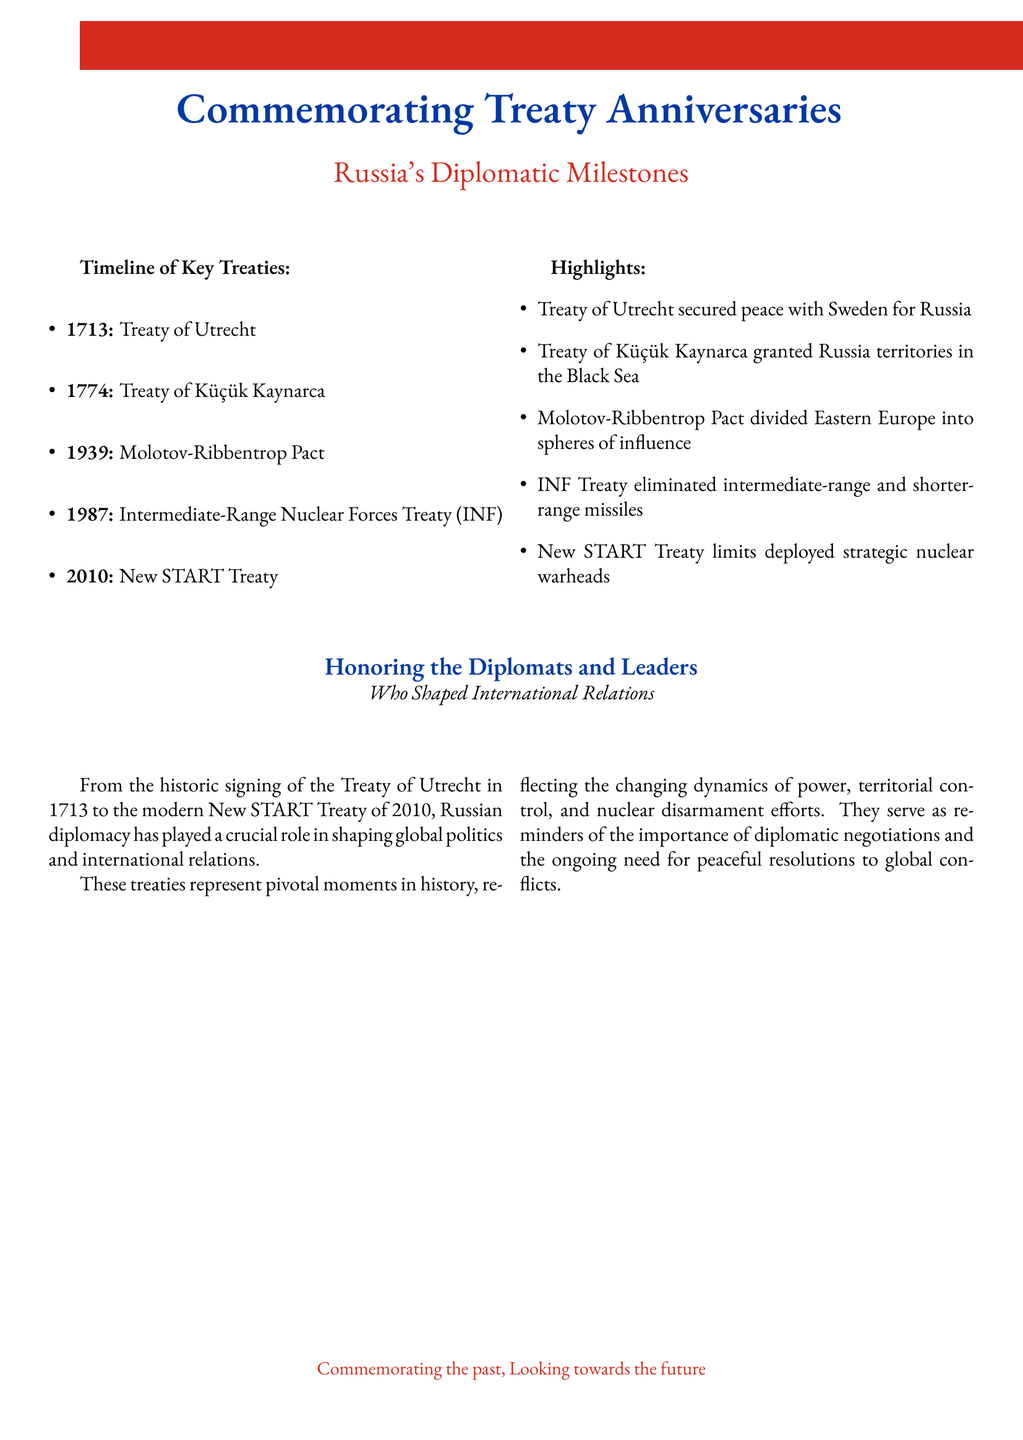what year was the Treaty of Utrecht signed? The Treaty of Utrecht was signed in 1713, as indicated in the timeline section of the document.
Answer: 1713 what treaty granted Russia territory in the Black Sea? The treaty that granted Russia territories in the Black Sea is the Treaty of Küçük Kaynarca, as noted in the highlights section.
Answer: Treaty of Küçük Kaynarca how many key treaties are listed in the document? There are five key treaties listed in the document's timeline.
Answer: five what is the significance of the Molotov-Ribbentrop Pact mentioned in the document? The significance of the Molotov-Ribbentrop Pact is that it divided Eastern Europe into spheres of influence, as outlined in the highlights.
Answer: divided Eastern Europe into spheres of influence which treaty is associated with nuclear disarmament efforts? The treaty associated with nuclear disarmament efforts mentioned in the document is the New START Treaty.
Answer: New START Treaty what is the primary focus of the document? The primary focus of the document is to commemorate pivotal treaties between Russia and other nations, highlighting their significance in international relations.
Answer: commemorating pivotal treaties who are honored for shaping international relations in the document? The document honors the diplomats and leaders who shaped international relations, as stated in the section heading.
Answer: diplomats and leaders what color is used to highlight the title in the document? The color used to highlight the title is russiablue.
Answer: russiablue 